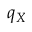Convert formula to latex. <formula><loc_0><loc_0><loc_500><loc_500>q _ { X }</formula> 